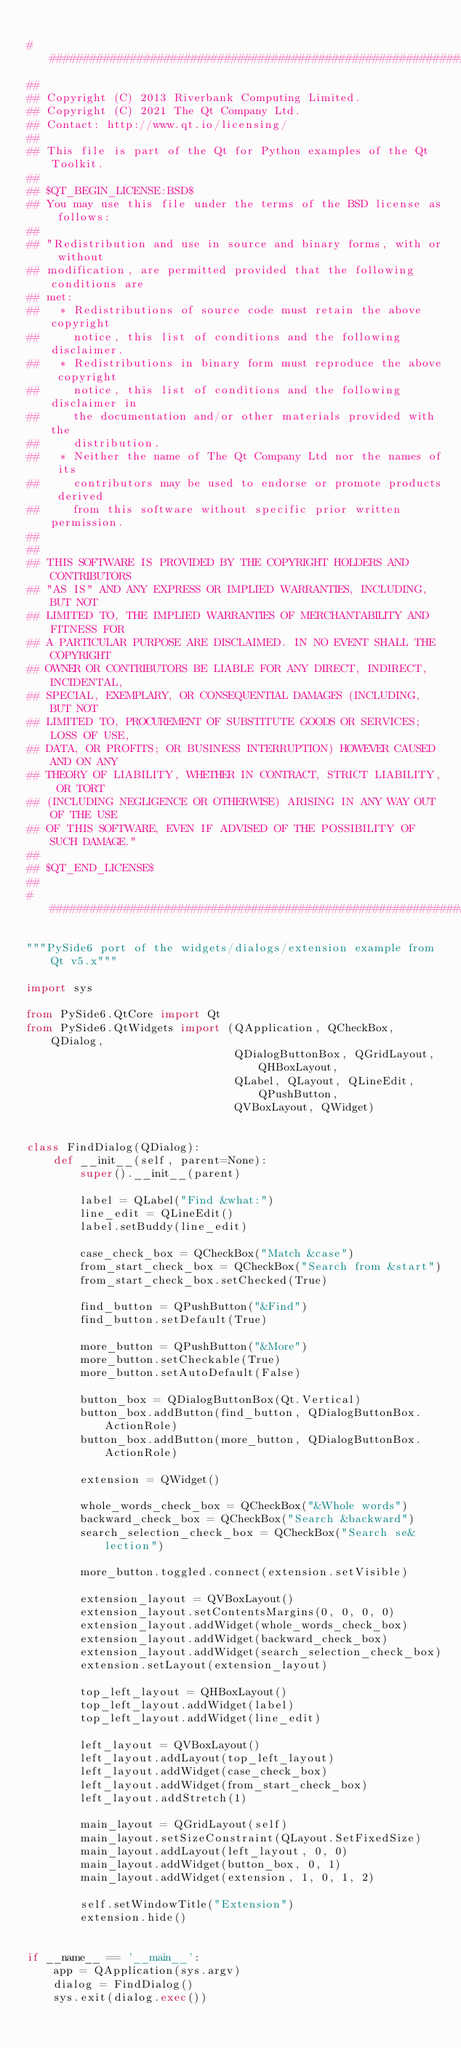<code> <loc_0><loc_0><loc_500><loc_500><_Python_>
#############################################################################
##
## Copyright (C) 2013 Riverbank Computing Limited.
## Copyright (C) 2021 The Qt Company Ltd.
## Contact: http://www.qt.io/licensing/
##
## This file is part of the Qt for Python examples of the Qt Toolkit.
##
## $QT_BEGIN_LICENSE:BSD$
## You may use this file under the terms of the BSD license as follows:
##
## "Redistribution and use in source and binary forms, with or without
## modification, are permitted provided that the following conditions are
## met:
##   * Redistributions of source code must retain the above copyright
##     notice, this list of conditions and the following disclaimer.
##   * Redistributions in binary form must reproduce the above copyright
##     notice, this list of conditions and the following disclaimer in
##     the documentation and/or other materials provided with the
##     distribution.
##   * Neither the name of The Qt Company Ltd nor the names of its
##     contributors may be used to endorse or promote products derived
##     from this software without specific prior written permission.
##
##
## THIS SOFTWARE IS PROVIDED BY THE COPYRIGHT HOLDERS AND CONTRIBUTORS
## "AS IS" AND ANY EXPRESS OR IMPLIED WARRANTIES, INCLUDING, BUT NOT
## LIMITED TO, THE IMPLIED WARRANTIES OF MERCHANTABILITY AND FITNESS FOR
## A PARTICULAR PURPOSE ARE DISCLAIMED. IN NO EVENT SHALL THE COPYRIGHT
## OWNER OR CONTRIBUTORS BE LIABLE FOR ANY DIRECT, INDIRECT, INCIDENTAL,
## SPECIAL, EXEMPLARY, OR CONSEQUENTIAL DAMAGES (INCLUDING, BUT NOT
## LIMITED TO, PROCUREMENT OF SUBSTITUTE GOODS OR SERVICES; LOSS OF USE,
## DATA, OR PROFITS; OR BUSINESS INTERRUPTION) HOWEVER CAUSED AND ON ANY
## THEORY OF LIABILITY, WHETHER IN CONTRACT, STRICT LIABILITY, OR TORT
## (INCLUDING NEGLIGENCE OR OTHERWISE) ARISING IN ANY WAY OUT OF THE USE
## OF THIS SOFTWARE, EVEN IF ADVISED OF THE POSSIBILITY OF SUCH DAMAGE."
##
## $QT_END_LICENSE$
##
#############################################################################

"""PySide6 port of the widgets/dialogs/extension example from Qt v5.x"""

import sys

from PySide6.QtCore import Qt
from PySide6.QtWidgets import (QApplication, QCheckBox, QDialog,
                               QDialogButtonBox, QGridLayout, QHBoxLayout,
                               QLabel, QLayout, QLineEdit, QPushButton,
                               QVBoxLayout, QWidget)


class FindDialog(QDialog):
    def __init__(self, parent=None):
        super().__init__(parent)

        label = QLabel("Find &what:")
        line_edit = QLineEdit()
        label.setBuddy(line_edit)

        case_check_box = QCheckBox("Match &case")
        from_start_check_box = QCheckBox("Search from &start")
        from_start_check_box.setChecked(True)

        find_button = QPushButton("&Find")
        find_button.setDefault(True)

        more_button = QPushButton("&More")
        more_button.setCheckable(True)
        more_button.setAutoDefault(False)

        button_box = QDialogButtonBox(Qt.Vertical)
        button_box.addButton(find_button, QDialogButtonBox.ActionRole)
        button_box.addButton(more_button, QDialogButtonBox.ActionRole)

        extension = QWidget()

        whole_words_check_box = QCheckBox("&Whole words")
        backward_check_box = QCheckBox("Search &backward")
        search_selection_check_box = QCheckBox("Search se&lection")

        more_button.toggled.connect(extension.setVisible)

        extension_layout = QVBoxLayout()
        extension_layout.setContentsMargins(0, 0, 0, 0)
        extension_layout.addWidget(whole_words_check_box)
        extension_layout.addWidget(backward_check_box)
        extension_layout.addWidget(search_selection_check_box)
        extension.setLayout(extension_layout)

        top_left_layout = QHBoxLayout()
        top_left_layout.addWidget(label)
        top_left_layout.addWidget(line_edit)

        left_layout = QVBoxLayout()
        left_layout.addLayout(top_left_layout)
        left_layout.addWidget(case_check_box)
        left_layout.addWidget(from_start_check_box)
        left_layout.addStretch(1)

        main_layout = QGridLayout(self)
        main_layout.setSizeConstraint(QLayout.SetFixedSize)
        main_layout.addLayout(left_layout, 0, 0)
        main_layout.addWidget(button_box, 0, 1)
        main_layout.addWidget(extension, 1, 0, 1, 2)

        self.setWindowTitle("Extension")
        extension.hide()


if __name__ == '__main__':
    app = QApplication(sys.argv)
    dialog = FindDialog()
    sys.exit(dialog.exec())
</code> 